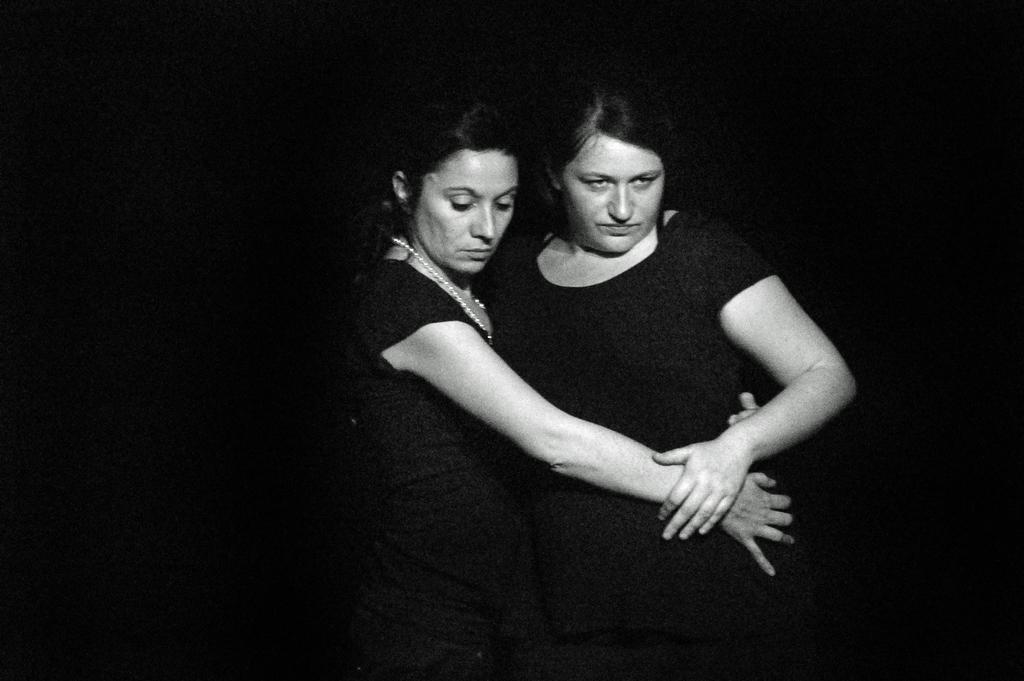Can you describe this image briefly? In this image we can see women standing and holding each other. 